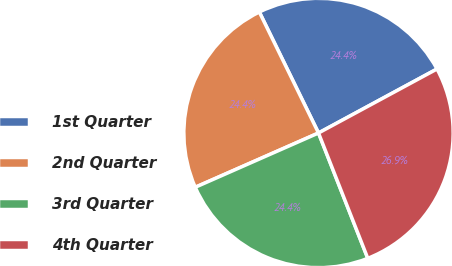Convert chart. <chart><loc_0><loc_0><loc_500><loc_500><pie_chart><fcel>1st Quarter<fcel>2nd Quarter<fcel>3rd Quarter<fcel>4th Quarter<nl><fcel>24.36%<fcel>24.36%<fcel>24.36%<fcel>26.92%<nl></chart> 